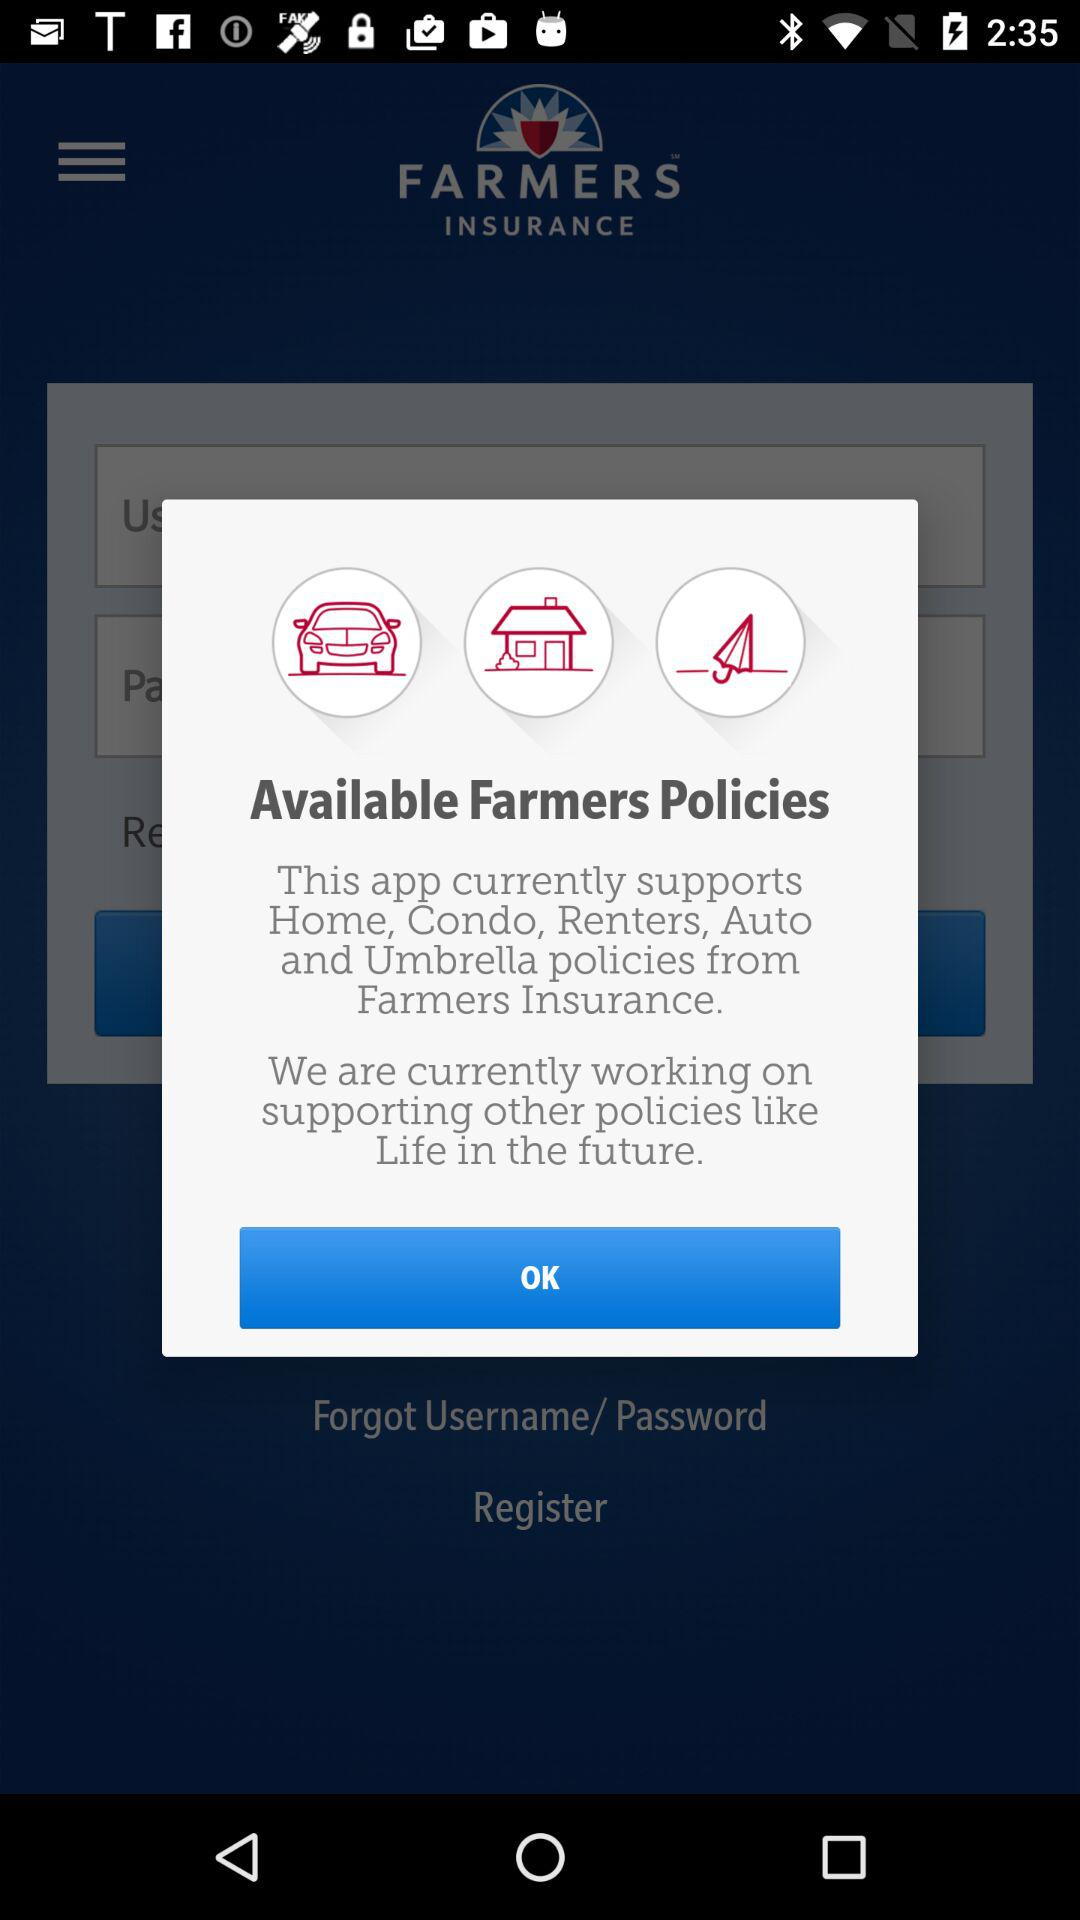How many policies are available from Farmers Insurance?
Answer the question using a single word or phrase. 5 